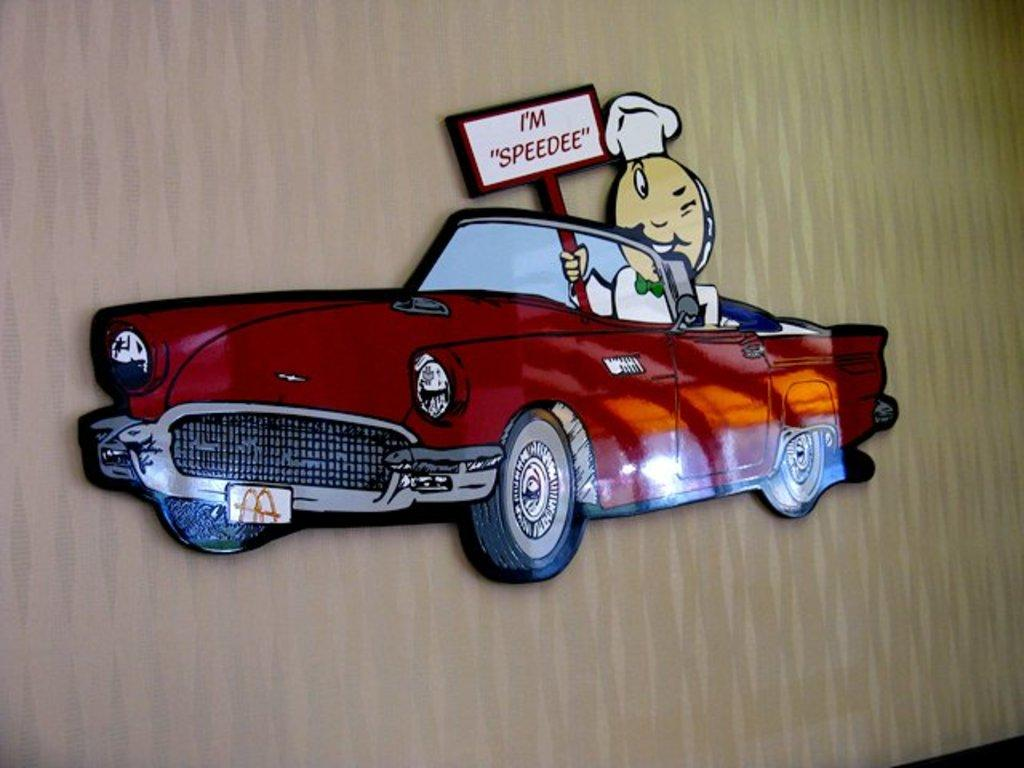What is the main subject of the image? There is a car in the image. Can you describe the color of the car? The car is dark red in color. Who or what is inside the car? A cartoon person is sitting in the car. What is the cartoon person holding? The cartoon person is holding a placard. What else can be seen in the image besides the car and the cartoon person? There is a board attached to a wall in the image. Can you tell me how long the trail behind the car is in the image? There is no trail visible behind the car in the image. What type of creature is sitting on the back of the cartoon person in the image? There is no creature sitting on the back of the cartoon person in the image. 